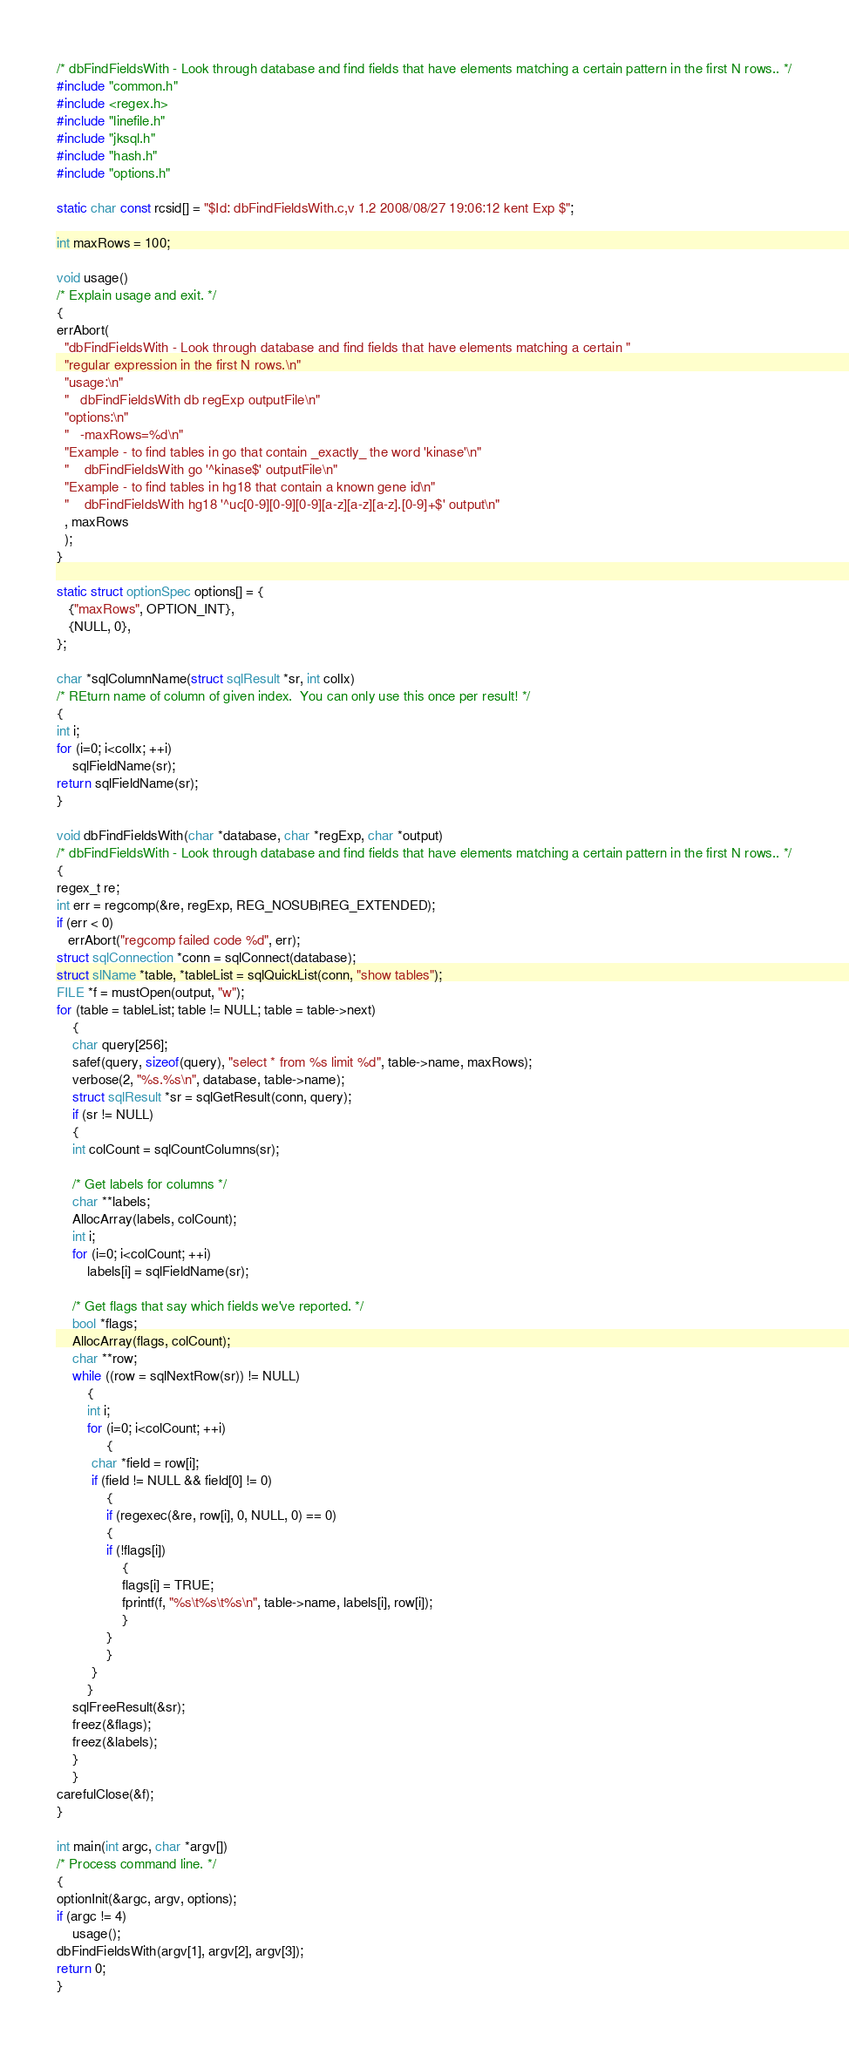Convert code to text. <code><loc_0><loc_0><loc_500><loc_500><_C_>/* dbFindFieldsWith - Look through database and find fields that have elements matching a certain pattern in the first N rows.. */
#include "common.h"
#include <regex.h>
#include "linefile.h"
#include "jksql.h"
#include "hash.h"
#include "options.h"

static char const rcsid[] = "$Id: dbFindFieldsWith.c,v 1.2 2008/08/27 19:06:12 kent Exp $";

int maxRows = 100;

void usage()
/* Explain usage and exit. */
{
errAbort(
  "dbFindFieldsWith - Look through database and find fields that have elements matching a certain "
  "regular expression in the first N rows.\n"
  "usage:\n"
  "   dbFindFieldsWith db regExp outputFile\n"
  "options:\n"
  "   -maxRows=%d\n"
  "Example - to find tables in go that contain _exactly_ the word 'kinase'\n"
  "    dbFindFieldsWith go '^kinase$' outputFile\n"
  "Example - to find tables in hg18 that contain a known gene id\n"
  "    dbFindFieldsWith hg18 '^uc[0-9][0-9][0-9][a-z][a-z][a-z].[0-9]+$' output\n"
  , maxRows
  );
}

static struct optionSpec options[] = {
   {"maxRows", OPTION_INT},
   {NULL, 0},
};

char *sqlColumnName(struct sqlResult *sr, int colIx)
/* REturn name of column of given index.  You can only use this once per result! */
{
int i;
for (i=0; i<colIx; ++i)
    sqlFieldName(sr);
return sqlFieldName(sr);
}

void dbFindFieldsWith(char *database, char *regExp, char *output)
/* dbFindFieldsWith - Look through database and find fields that have elements matching a certain pattern in the first N rows.. */
{
regex_t re;
int err = regcomp(&re, regExp, REG_NOSUB|REG_EXTENDED);
if (err < 0)
   errAbort("regcomp failed code %d", err);
struct sqlConnection *conn = sqlConnect(database);
struct slName *table, *tableList = sqlQuickList(conn, "show tables");
FILE *f = mustOpen(output, "w");
for (table = tableList; table != NULL; table = table->next)
    {
    char query[256];
    safef(query, sizeof(query), "select * from %s limit %d", table->name, maxRows);
    verbose(2, "%s.%s\n", database, table->name);
    struct sqlResult *sr = sqlGetResult(conn, query);
    if (sr != NULL)
	{
	int colCount = sqlCountColumns(sr);

	/* Get labels for columns */
	char **labels;
	AllocArray(labels, colCount);
	int i;
	for (i=0; i<colCount; ++i)
	    labels[i] = sqlFieldName(sr);

	/* Get flags that say which fields we've reported. */
	bool *flags;
	AllocArray(flags, colCount);
	char **row;
	while ((row = sqlNextRow(sr)) != NULL)
	    {
	    int i;
	    for (i=0; i<colCount; ++i)
	         {
		 char *field = row[i];
		 if (field != NULL && field[0] != 0)
		     {
		     if (regexec(&re, row[i], 0, NULL, 0) == 0)
			 {
			 if (!flags[i])
			     {
			     flags[i] = TRUE;
			     fprintf(f, "%s\t%s\t%s\n", table->name, labels[i], row[i]);
			     }
			 }
		     }
		 }
	    }
	sqlFreeResult(&sr);
	freez(&flags);
	freez(&labels);
	}
    }
carefulClose(&f);
}

int main(int argc, char *argv[])
/* Process command line. */
{
optionInit(&argc, argv, options);
if (argc != 4)
    usage();
dbFindFieldsWith(argv[1], argv[2], argv[3]);
return 0;
}
</code> 